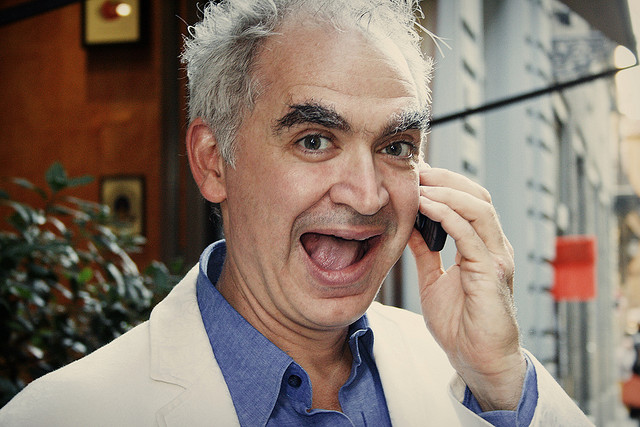<image>Has this person recently had an eyebrow waxing? I don't know if this person recently had an eyebrow waxing. Has this person recently had an eyebrow waxing? I am not sure if this person has recently had an eyebrow waxing. It can be seen both 'yes' and 'no' answers. 